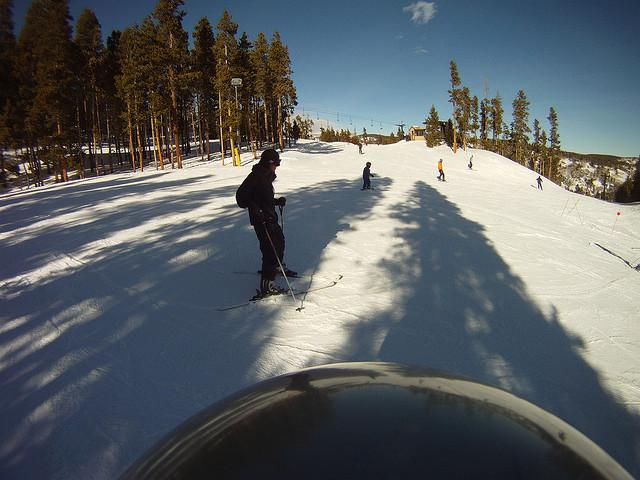What surrounds these people? trees 